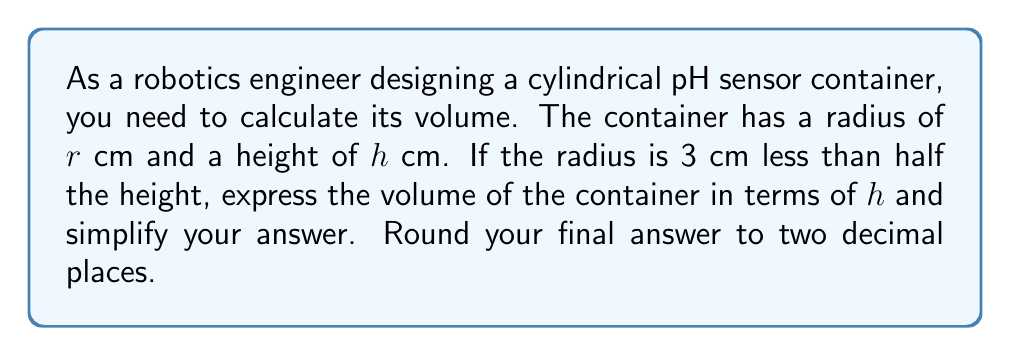Help me with this question. Let's approach this step-by-step:

1) The volume of a cylinder is given by the formula:
   $$V = \pi r^2 h$$

2) We're told that the radius is 3 cm less than half the height. We can express this as:
   $$r = \frac{h}{2} - 3$$

3) Now, let's substitute this expression for $r$ into our volume formula:
   $$V = \pi (\frac{h}{2} - 3)^2 h$$

4) Let's expand the squared term:
   $$V = \pi (\frac{h^2}{4} - 3h + 9) h$$

5) Distribute $h$:
   $$V = \pi (\frac{h^3}{4} - 3h^2 + 9h)$$

6) Simplify:
   $$V = \frac{\pi h^3}{4} - 3\pi h^2 + 9\pi h$$

7) Factor out $\pi h$:
   $$V = \pi h(\frac{h^2}{4} - 3h + 9)$$

8) This is our final algebraic expression. To get a numerical answer, we would need a value for $h$. Since we don't have one, we'll leave it in this form.
Answer: $$V = \pi h(\frac{h^2}{4} - 3h + 9)$$ cubic cm 